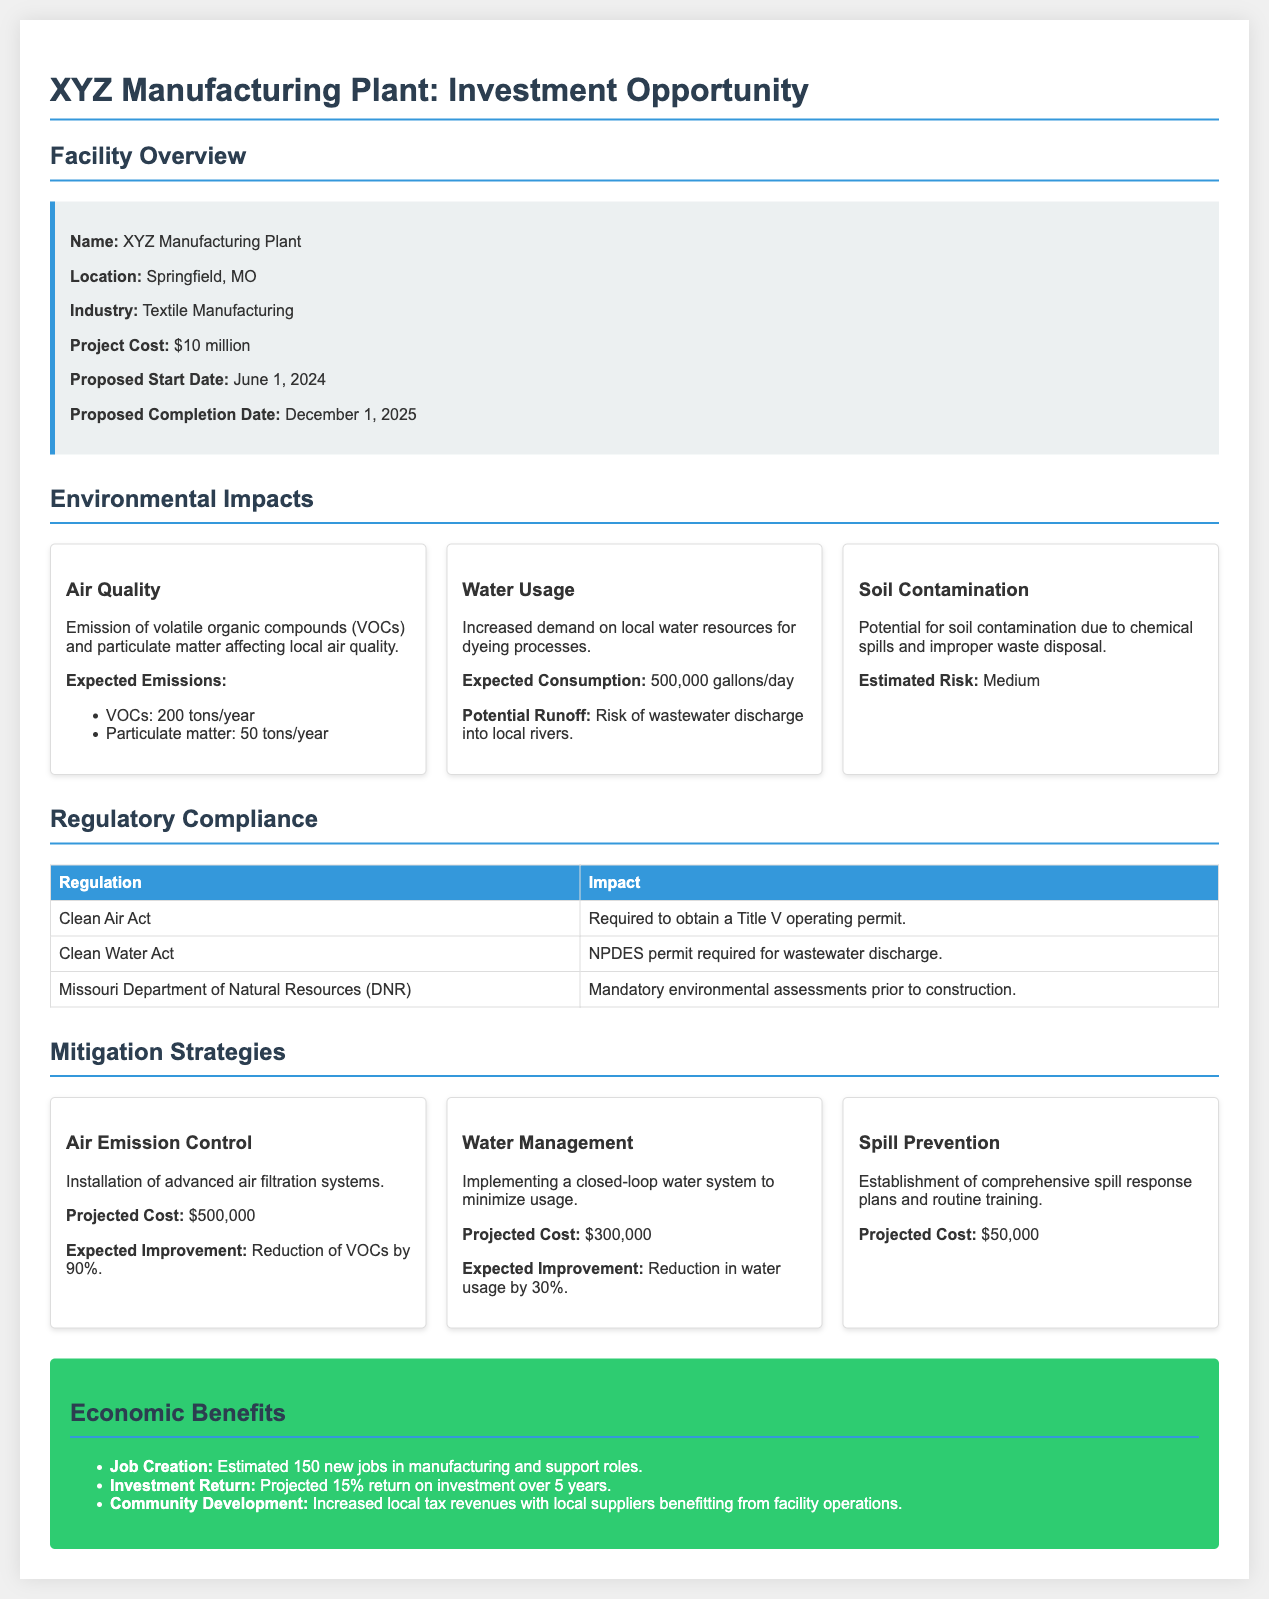What is the name of the facility? The name of the facility is mentioned in the document's header section as XYZ Manufacturing Plant.
Answer: XYZ Manufacturing Plant Where is the facility located? The location of the facility is specified in the overview section as Springfield, MO.
Answer: Springfield, MO What is the proposed start date of the project? The proposed start date is clearly noted in the overview as June 1, 2024.
Answer: June 1, 2024 How much water is expected to be consumed daily? The document states the expected water consumption in the environmental impacts section as 500,000 gallons/day.
Answer: 500,000 gallons/day What is the projected cost for air emission control? The mitigation strategies section lists the projected cost for air emission control as $500,000.
Answer: $500,000 What is the potential risk of soil contamination? The estimated risk of soil contamination is categorized in the environmental impacts section as Medium.
Answer: Medium Which regulation requires an NPDES permit? The Clean Water Act is identified in the regulatory compliance section as the regulation requiring an NPDES permit.
Answer: Clean Water Act What is the expected reduction in water usage from implementing the water management strategy? The expected improvement in water management is described in the mitigation strategies section as a reduction in water usage by 30%.
Answer: 30% How many new jobs are estimated to be created? The economic benefits section states that an estimated 150 new jobs will be created.
Answer: 150 new jobs 